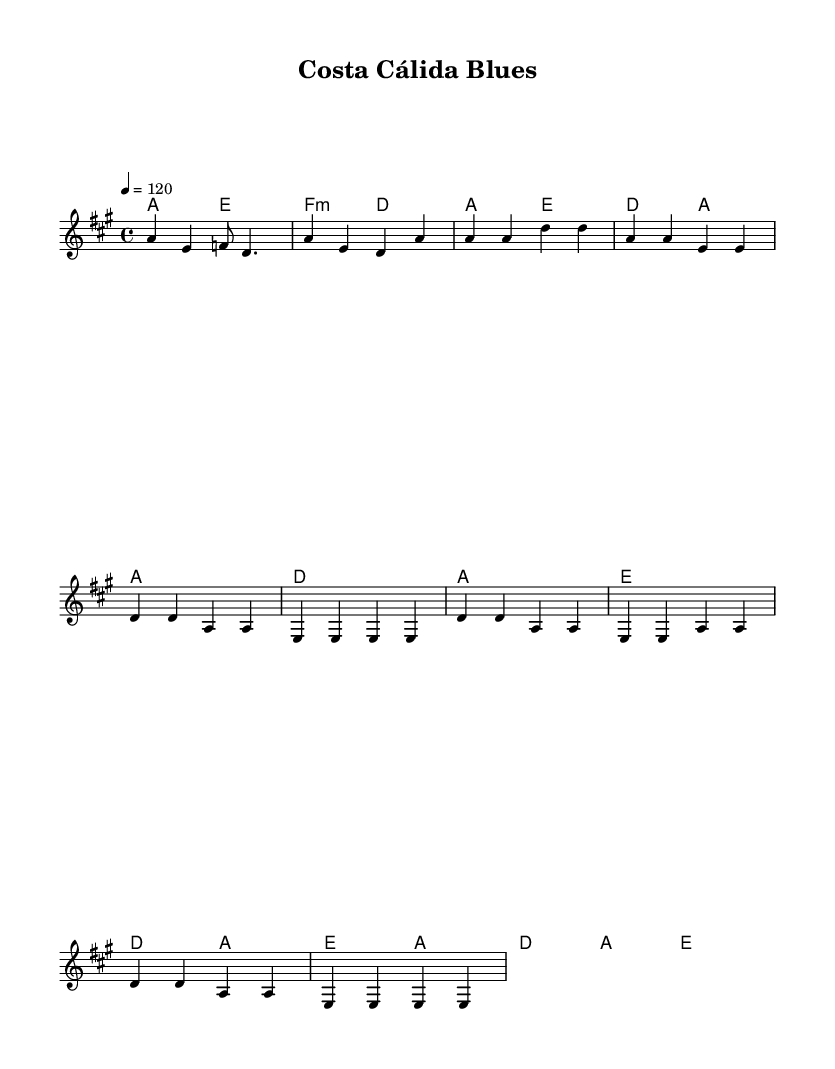What is the key signature of this music? The key signature shows one sharp, which indicates that the music is in A major.
Answer: A major What is the time signature of this music? The time signature is indicated at the beginning of the sheet music, showing 4 beats per measure.
Answer: 4/4 What is the tempo marking of this piece? The tempo is indicated by "4 = 120," meaning there are 120 beats per minute in a quarter note.
Answer: 120 How many measures are in the verse section? The verse is specified with 4 lines, and each line has 4 measures, totaling 16 measures in the verse section.
Answer: 16 Which chord appears at the beginning of the chorus? By checking the harmonies provided, it starts with the D chord in the first measure of the chorus.
Answer: D What type of music is this piece classified as? The sheet music explicitly indicates it as a "Blues" genre, with an upbeat Spanish influence.
Answer: Blues What is the chord progression of the introductory section? The introductory section shows a sequence of chords: A, E, F minor, and D, which are four different chords played in that order.
Answer: A, E, F minor, D 